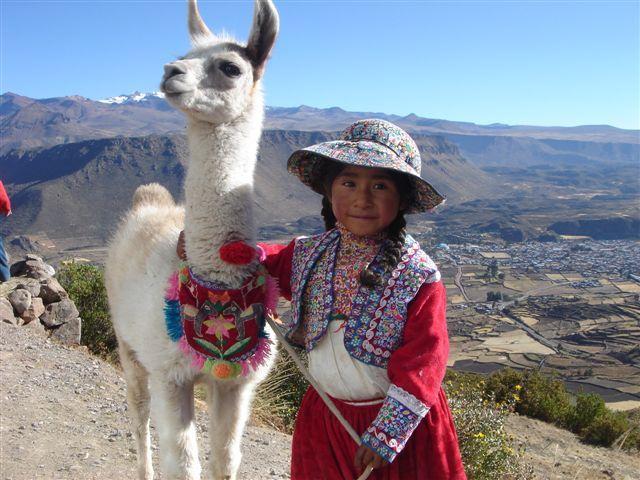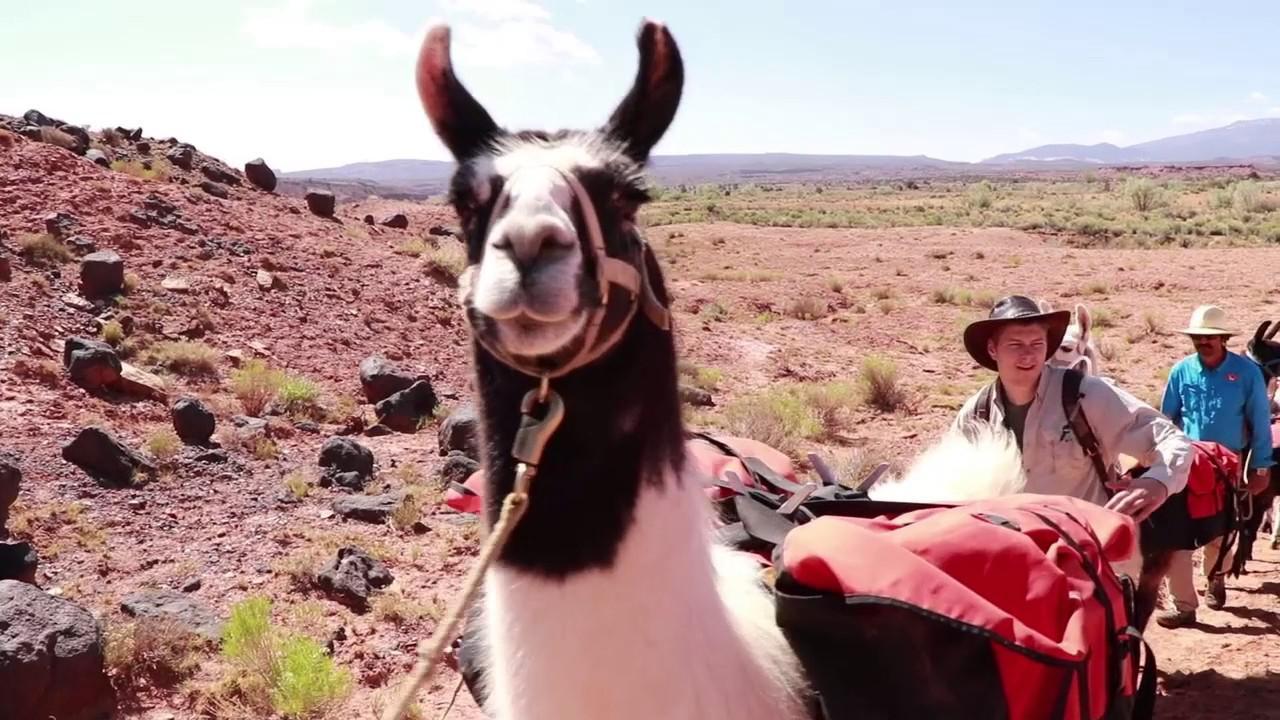The first image is the image on the left, the second image is the image on the right. For the images shown, is this caption "Both images contain people and llamas." true? Answer yes or no. Yes. The first image is the image on the left, the second image is the image on the right. Assess this claim about the two images: "A camera-facing man and woman are standing between two pack-wearing llamas and in front of at least one peak.". Correct or not? Answer yes or no. No. 